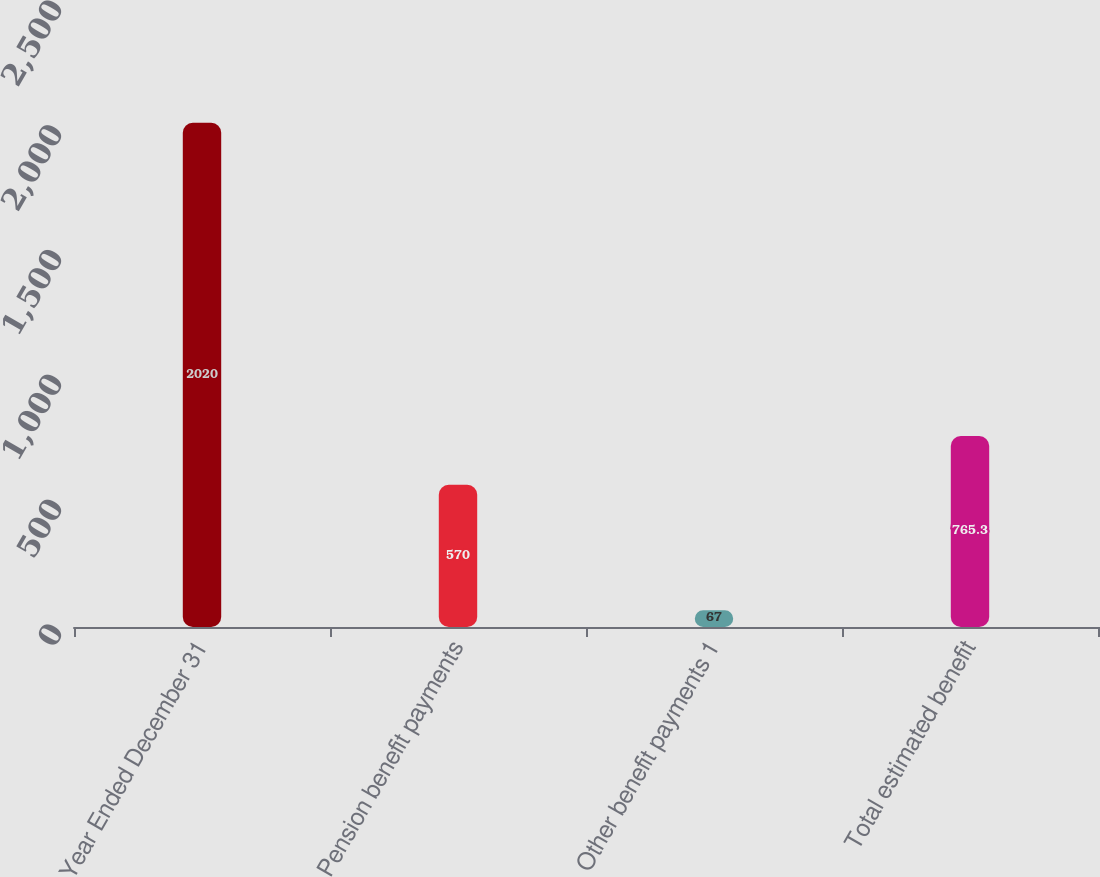<chart> <loc_0><loc_0><loc_500><loc_500><bar_chart><fcel>Year Ended December 31<fcel>Pension benefit payments<fcel>Other benefit payments 1<fcel>Total estimated benefit<nl><fcel>2020<fcel>570<fcel>67<fcel>765.3<nl></chart> 